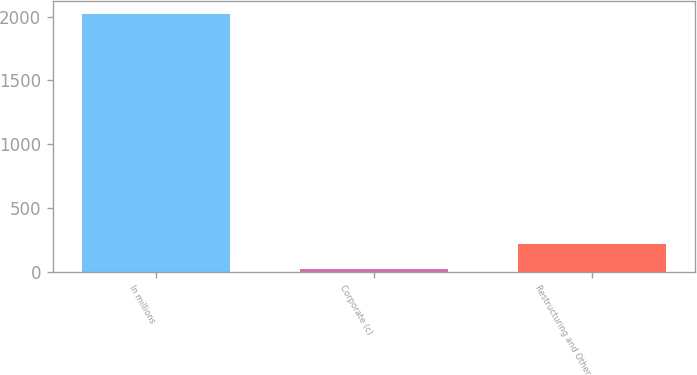<chart> <loc_0><loc_0><loc_500><loc_500><bar_chart><fcel>In millions<fcel>Corporate (c)<fcel>Restructuring and Other<nl><fcel>2018<fcel>21<fcel>220.7<nl></chart> 